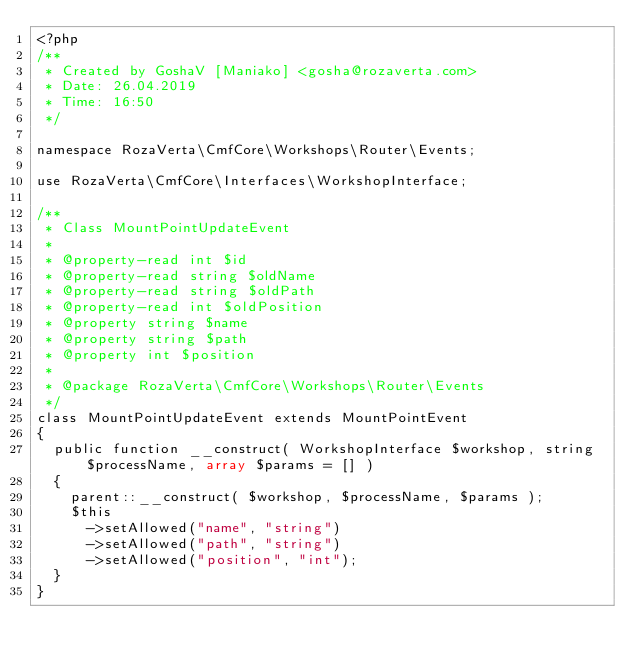<code> <loc_0><loc_0><loc_500><loc_500><_PHP_><?php
/**
 * Created by GoshaV [Maniako] <gosha@rozaverta.com>
 * Date: 26.04.2019
 * Time: 16:50
 */

namespace RozaVerta\CmfCore\Workshops\Router\Events;

use RozaVerta\CmfCore\Interfaces\WorkshopInterface;

/**
 * Class MountPointUpdateEvent
 *
 * @property-read int $id
 * @property-read string $oldName
 * @property-read string $oldPath
 * @property-read int $oldPosition
 * @property string $name
 * @property string $path
 * @property int $position
 *
 * @package RozaVerta\CmfCore\Workshops\Router\Events
 */
class MountPointUpdateEvent extends MountPointEvent
{
	public function __construct( WorkshopInterface $workshop, string $processName, array $params = [] )
	{
		parent::__construct( $workshop, $processName, $params );
		$this
			->setAllowed("name", "string")
			->setAllowed("path", "string")
			->setAllowed("position", "int");
	}
}</code> 